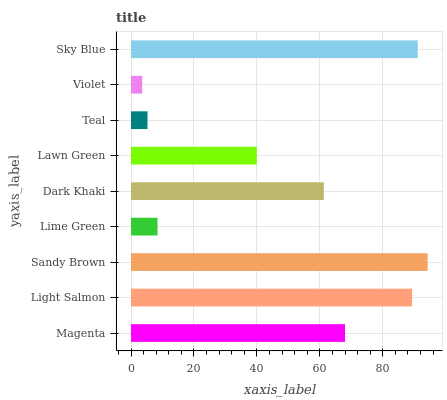Is Violet the minimum?
Answer yes or no. Yes. Is Sandy Brown the maximum?
Answer yes or no. Yes. Is Light Salmon the minimum?
Answer yes or no. No. Is Light Salmon the maximum?
Answer yes or no. No. Is Light Salmon greater than Magenta?
Answer yes or no. Yes. Is Magenta less than Light Salmon?
Answer yes or no. Yes. Is Magenta greater than Light Salmon?
Answer yes or no. No. Is Light Salmon less than Magenta?
Answer yes or no. No. Is Dark Khaki the high median?
Answer yes or no. Yes. Is Dark Khaki the low median?
Answer yes or no. Yes. Is Teal the high median?
Answer yes or no. No. Is Lawn Green the low median?
Answer yes or no. No. 